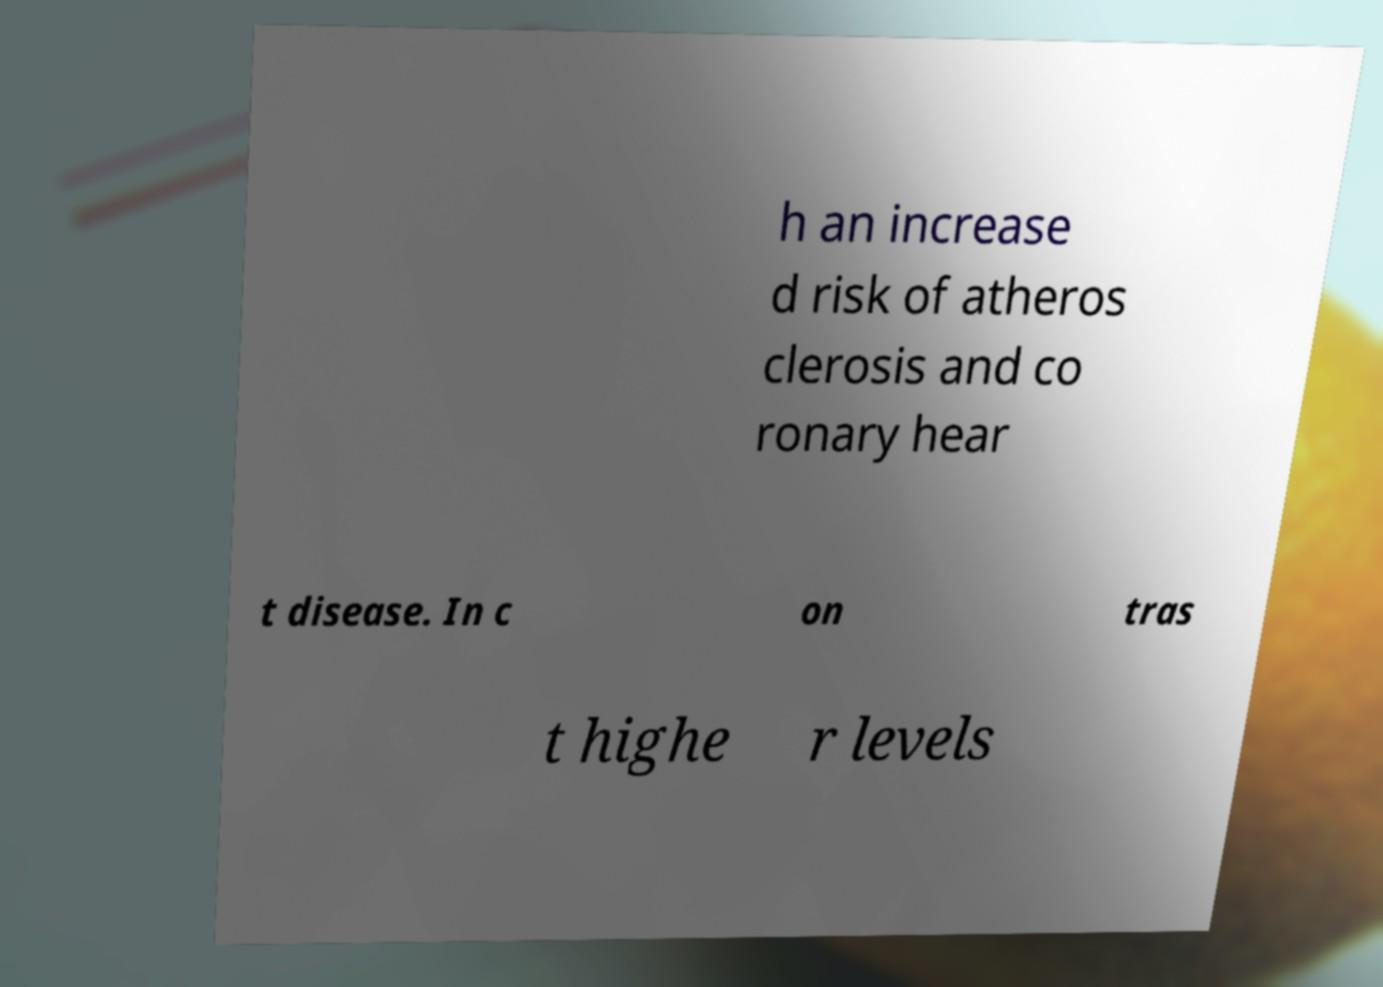Can you accurately transcribe the text from the provided image for me? h an increase d risk of atheros clerosis and co ronary hear t disease. In c on tras t highe r levels 